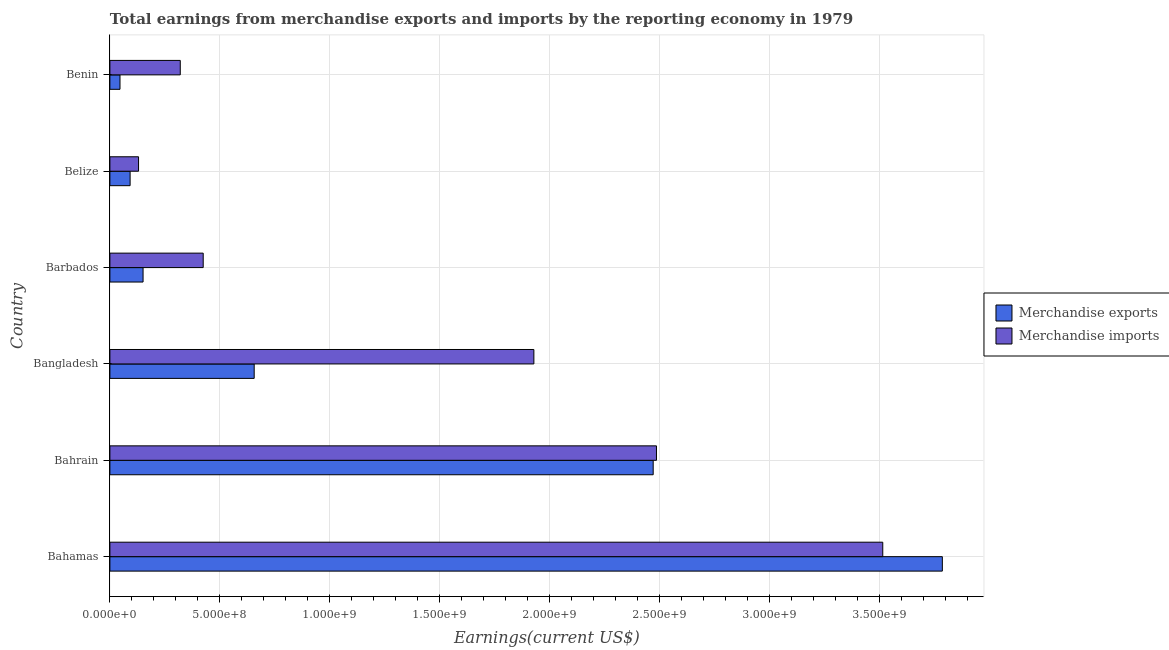How many different coloured bars are there?
Your response must be concise. 2. Are the number of bars per tick equal to the number of legend labels?
Keep it short and to the point. Yes. What is the label of the 2nd group of bars from the top?
Make the answer very short. Belize. In how many cases, is the number of bars for a given country not equal to the number of legend labels?
Give a very brief answer. 0. What is the earnings from merchandise exports in Belize?
Your answer should be compact. 9.19e+07. Across all countries, what is the maximum earnings from merchandise imports?
Your response must be concise. 3.51e+09. Across all countries, what is the minimum earnings from merchandise exports?
Your answer should be compact. 4.59e+07. In which country was the earnings from merchandise exports maximum?
Provide a succinct answer. Bahamas. In which country was the earnings from merchandise exports minimum?
Make the answer very short. Benin. What is the total earnings from merchandise imports in the graph?
Make the answer very short. 8.80e+09. What is the difference between the earnings from merchandise exports in Bahamas and that in Benin?
Provide a succinct answer. 3.74e+09. What is the difference between the earnings from merchandise imports in Bangladesh and the earnings from merchandise exports in Bahamas?
Offer a very short reply. -1.86e+09. What is the average earnings from merchandise exports per country?
Your response must be concise. 1.20e+09. What is the difference between the earnings from merchandise exports and earnings from merchandise imports in Bahamas?
Make the answer very short. 2.71e+08. In how many countries, is the earnings from merchandise imports greater than 3500000000 US$?
Give a very brief answer. 1. What is the ratio of the earnings from merchandise imports in Bangladesh to that in Belize?
Make the answer very short. 14.79. What is the difference between the highest and the second highest earnings from merchandise exports?
Your answer should be very brief. 1.31e+09. What is the difference between the highest and the lowest earnings from merchandise exports?
Make the answer very short. 3.74e+09. Is the sum of the earnings from merchandise exports in Bangladesh and Benin greater than the maximum earnings from merchandise imports across all countries?
Your response must be concise. No. What does the 2nd bar from the top in Belize represents?
Give a very brief answer. Merchandise exports. What does the 2nd bar from the bottom in Benin represents?
Provide a short and direct response. Merchandise imports. Are all the bars in the graph horizontal?
Provide a short and direct response. Yes. How many countries are there in the graph?
Ensure brevity in your answer.  6. What is the difference between two consecutive major ticks on the X-axis?
Provide a succinct answer. 5.00e+08. Are the values on the major ticks of X-axis written in scientific E-notation?
Make the answer very short. Yes. How many legend labels are there?
Your answer should be very brief. 2. How are the legend labels stacked?
Provide a short and direct response. Vertical. What is the title of the graph?
Keep it short and to the point. Total earnings from merchandise exports and imports by the reporting economy in 1979. Does "Services" appear as one of the legend labels in the graph?
Your answer should be very brief. No. What is the label or title of the X-axis?
Ensure brevity in your answer.  Earnings(current US$). What is the label or title of the Y-axis?
Give a very brief answer. Country. What is the Earnings(current US$) in Merchandise exports in Bahamas?
Offer a very short reply. 3.78e+09. What is the Earnings(current US$) in Merchandise imports in Bahamas?
Provide a short and direct response. 3.51e+09. What is the Earnings(current US$) of Merchandise exports in Bahrain?
Ensure brevity in your answer.  2.47e+09. What is the Earnings(current US$) in Merchandise imports in Bahrain?
Offer a very short reply. 2.49e+09. What is the Earnings(current US$) of Merchandise exports in Bangladesh?
Your response must be concise. 6.56e+08. What is the Earnings(current US$) in Merchandise imports in Bangladesh?
Keep it short and to the point. 1.93e+09. What is the Earnings(current US$) in Merchandise exports in Barbados?
Offer a terse response. 1.51e+08. What is the Earnings(current US$) of Merchandise imports in Barbados?
Provide a succinct answer. 4.24e+08. What is the Earnings(current US$) of Merchandise exports in Belize?
Give a very brief answer. 9.19e+07. What is the Earnings(current US$) of Merchandise imports in Belize?
Your answer should be very brief. 1.30e+08. What is the Earnings(current US$) in Merchandise exports in Benin?
Offer a terse response. 4.59e+07. What is the Earnings(current US$) of Merchandise imports in Benin?
Your answer should be compact. 3.20e+08. Across all countries, what is the maximum Earnings(current US$) in Merchandise exports?
Offer a terse response. 3.78e+09. Across all countries, what is the maximum Earnings(current US$) in Merchandise imports?
Offer a terse response. 3.51e+09. Across all countries, what is the minimum Earnings(current US$) in Merchandise exports?
Your answer should be very brief. 4.59e+07. Across all countries, what is the minimum Earnings(current US$) of Merchandise imports?
Keep it short and to the point. 1.30e+08. What is the total Earnings(current US$) of Merchandise exports in the graph?
Ensure brevity in your answer.  7.20e+09. What is the total Earnings(current US$) in Merchandise imports in the graph?
Give a very brief answer. 8.80e+09. What is the difference between the Earnings(current US$) in Merchandise exports in Bahamas and that in Bahrain?
Your answer should be compact. 1.31e+09. What is the difference between the Earnings(current US$) of Merchandise imports in Bahamas and that in Bahrain?
Provide a succinct answer. 1.03e+09. What is the difference between the Earnings(current US$) of Merchandise exports in Bahamas and that in Bangladesh?
Your answer should be compact. 3.13e+09. What is the difference between the Earnings(current US$) of Merchandise imports in Bahamas and that in Bangladesh?
Your answer should be compact. 1.59e+09. What is the difference between the Earnings(current US$) of Merchandise exports in Bahamas and that in Barbados?
Provide a short and direct response. 3.63e+09. What is the difference between the Earnings(current US$) in Merchandise imports in Bahamas and that in Barbados?
Your response must be concise. 3.09e+09. What is the difference between the Earnings(current US$) of Merchandise exports in Bahamas and that in Belize?
Give a very brief answer. 3.69e+09. What is the difference between the Earnings(current US$) of Merchandise imports in Bahamas and that in Belize?
Provide a succinct answer. 3.38e+09. What is the difference between the Earnings(current US$) of Merchandise exports in Bahamas and that in Benin?
Offer a very short reply. 3.74e+09. What is the difference between the Earnings(current US$) of Merchandise imports in Bahamas and that in Benin?
Give a very brief answer. 3.19e+09. What is the difference between the Earnings(current US$) of Merchandise exports in Bahrain and that in Bangladesh?
Provide a short and direct response. 1.81e+09. What is the difference between the Earnings(current US$) in Merchandise imports in Bahrain and that in Bangladesh?
Offer a very short reply. 5.57e+08. What is the difference between the Earnings(current US$) in Merchandise exports in Bahrain and that in Barbados?
Your response must be concise. 2.32e+09. What is the difference between the Earnings(current US$) of Merchandise imports in Bahrain and that in Barbados?
Ensure brevity in your answer.  2.06e+09. What is the difference between the Earnings(current US$) in Merchandise exports in Bahrain and that in Belize?
Provide a succinct answer. 2.38e+09. What is the difference between the Earnings(current US$) in Merchandise imports in Bahrain and that in Belize?
Your answer should be compact. 2.35e+09. What is the difference between the Earnings(current US$) in Merchandise exports in Bahrain and that in Benin?
Provide a short and direct response. 2.42e+09. What is the difference between the Earnings(current US$) in Merchandise imports in Bahrain and that in Benin?
Your answer should be very brief. 2.17e+09. What is the difference between the Earnings(current US$) of Merchandise exports in Bangladesh and that in Barbados?
Your answer should be very brief. 5.05e+08. What is the difference between the Earnings(current US$) in Merchandise imports in Bangladesh and that in Barbados?
Your answer should be very brief. 1.50e+09. What is the difference between the Earnings(current US$) of Merchandise exports in Bangladesh and that in Belize?
Provide a short and direct response. 5.64e+08. What is the difference between the Earnings(current US$) in Merchandise imports in Bangladesh and that in Belize?
Your response must be concise. 1.80e+09. What is the difference between the Earnings(current US$) in Merchandise exports in Bangladesh and that in Benin?
Offer a very short reply. 6.10e+08. What is the difference between the Earnings(current US$) in Merchandise imports in Bangladesh and that in Benin?
Offer a terse response. 1.61e+09. What is the difference between the Earnings(current US$) in Merchandise exports in Barbados and that in Belize?
Your answer should be compact. 5.89e+07. What is the difference between the Earnings(current US$) of Merchandise imports in Barbados and that in Belize?
Keep it short and to the point. 2.94e+08. What is the difference between the Earnings(current US$) of Merchandise exports in Barbados and that in Benin?
Your response must be concise. 1.05e+08. What is the difference between the Earnings(current US$) in Merchandise imports in Barbados and that in Benin?
Provide a short and direct response. 1.04e+08. What is the difference between the Earnings(current US$) of Merchandise exports in Belize and that in Benin?
Your answer should be compact. 4.60e+07. What is the difference between the Earnings(current US$) of Merchandise imports in Belize and that in Benin?
Make the answer very short. -1.90e+08. What is the difference between the Earnings(current US$) of Merchandise exports in Bahamas and the Earnings(current US$) of Merchandise imports in Bahrain?
Offer a terse response. 1.30e+09. What is the difference between the Earnings(current US$) of Merchandise exports in Bahamas and the Earnings(current US$) of Merchandise imports in Bangladesh?
Offer a terse response. 1.86e+09. What is the difference between the Earnings(current US$) of Merchandise exports in Bahamas and the Earnings(current US$) of Merchandise imports in Barbados?
Your answer should be very brief. 3.36e+09. What is the difference between the Earnings(current US$) in Merchandise exports in Bahamas and the Earnings(current US$) in Merchandise imports in Belize?
Your answer should be compact. 3.65e+09. What is the difference between the Earnings(current US$) of Merchandise exports in Bahamas and the Earnings(current US$) of Merchandise imports in Benin?
Keep it short and to the point. 3.46e+09. What is the difference between the Earnings(current US$) of Merchandise exports in Bahrain and the Earnings(current US$) of Merchandise imports in Bangladesh?
Offer a terse response. 5.42e+08. What is the difference between the Earnings(current US$) of Merchandise exports in Bahrain and the Earnings(current US$) of Merchandise imports in Barbados?
Offer a terse response. 2.05e+09. What is the difference between the Earnings(current US$) in Merchandise exports in Bahrain and the Earnings(current US$) in Merchandise imports in Belize?
Offer a very short reply. 2.34e+09. What is the difference between the Earnings(current US$) of Merchandise exports in Bahrain and the Earnings(current US$) of Merchandise imports in Benin?
Give a very brief answer. 2.15e+09. What is the difference between the Earnings(current US$) in Merchandise exports in Bangladesh and the Earnings(current US$) in Merchandise imports in Barbados?
Make the answer very short. 2.32e+08. What is the difference between the Earnings(current US$) in Merchandise exports in Bangladesh and the Earnings(current US$) in Merchandise imports in Belize?
Provide a succinct answer. 5.26e+08. What is the difference between the Earnings(current US$) of Merchandise exports in Bangladesh and the Earnings(current US$) of Merchandise imports in Benin?
Offer a terse response. 3.36e+08. What is the difference between the Earnings(current US$) in Merchandise exports in Barbados and the Earnings(current US$) in Merchandise imports in Belize?
Your answer should be very brief. 2.05e+07. What is the difference between the Earnings(current US$) in Merchandise exports in Barbados and the Earnings(current US$) in Merchandise imports in Benin?
Make the answer very short. -1.69e+08. What is the difference between the Earnings(current US$) of Merchandise exports in Belize and the Earnings(current US$) of Merchandise imports in Benin?
Ensure brevity in your answer.  -2.28e+08. What is the average Earnings(current US$) in Merchandise exports per country?
Keep it short and to the point. 1.20e+09. What is the average Earnings(current US$) in Merchandise imports per country?
Give a very brief answer. 1.47e+09. What is the difference between the Earnings(current US$) of Merchandise exports and Earnings(current US$) of Merchandise imports in Bahamas?
Give a very brief answer. 2.71e+08. What is the difference between the Earnings(current US$) of Merchandise exports and Earnings(current US$) of Merchandise imports in Bahrain?
Provide a succinct answer. -1.50e+07. What is the difference between the Earnings(current US$) in Merchandise exports and Earnings(current US$) in Merchandise imports in Bangladesh?
Your answer should be compact. -1.27e+09. What is the difference between the Earnings(current US$) in Merchandise exports and Earnings(current US$) in Merchandise imports in Barbados?
Keep it short and to the point. -2.73e+08. What is the difference between the Earnings(current US$) of Merchandise exports and Earnings(current US$) of Merchandise imports in Belize?
Offer a terse response. -3.84e+07. What is the difference between the Earnings(current US$) in Merchandise exports and Earnings(current US$) in Merchandise imports in Benin?
Offer a terse response. -2.74e+08. What is the ratio of the Earnings(current US$) of Merchandise exports in Bahamas to that in Bahrain?
Make the answer very short. 1.53. What is the ratio of the Earnings(current US$) of Merchandise imports in Bahamas to that in Bahrain?
Provide a short and direct response. 1.41. What is the ratio of the Earnings(current US$) of Merchandise exports in Bahamas to that in Bangladesh?
Offer a very short reply. 5.77. What is the ratio of the Earnings(current US$) in Merchandise imports in Bahamas to that in Bangladesh?
Offer a terse response. 1.82. What is the ratio of the Earnings(current US$) in Merchandise exports in Bahamas to that in Barbados?
Give a very brief answer. 25.09. What is the ratio of the Earnings(current US$) in Merchandise imports in Bahamas to that in Barbados?
Make the answer very short. 8.28. What is the ratio of the Earnings(current US$) in Merchandise exports in Bahamas to that in Belize?
Your response must be concise. 41.17. What is the ratio of the Earnings(current US$) of Merchandise imports in Bahamas to that in Belize?
Keep it short and to the point. 26.97. What is the ratio of the Earnings(current US$) in Merchandise exports in Bahamas to that in Benin?
Ensure brevity in your answer.  82.38. What is the ratio of the Earnings(current US$) in Merchandise imports in Bahamas to that in Benin?
Provide a succinct answer. 10.98. What is the ratio of the Earnings(current US$) of Merchandise exports in Bahrain to that in Bangladesh?
Keep it short and to the point. 3.77. What is the ratio of the Earnings(current US$) in Merchandise imports in Bahrain to that in Bangladesh?
Offer a terse response. 1.29. What is the ratio of the Earnings(current US$) of Merchandise exports in Bahrain to that in Barbados?
Provide a succinct answer. 16.38. What is the ratio of the Earnings(current US$) in Merchandise imports in Bahrain to that in Barbados?
Offer a terse response. 5.86. What is the ratio of the Earnings(current US$) in Merchandise exports in Bahrain to that in Belize?
Provide a short and direct response. 26.87. What is the ratio of the Earnings(current US$) in Merchandise imports in Bahrain to that in Belize?
Provide a short and direct response. 19.07. What is the ratio of the Earnings(current US$) of Merchandise exports in Bahrain to that in Benin?
Offer a very short reply. 53.76. What is the ratio of the Earnings(current US$) of Merchandise imports in Bahrain to that in Benin?
Offer a terse response. 7.77. What is the ratio of the Earnings(current US$) of Merchandise exports in Bangladesh to that in Barbados?
Give a very brief answer. 4.35. What is the ratio of the Earnings(current US$) in Merchandise imports in Bangladesh to that in Barbados?
Ensure brevity in your answer.  4.54. What is the ratio of the Earnings(current US$) of Merchandise exports in Bangladesh to that in Belize?
Offer a terse response. 7.14. What is the ratio of the Earnings(current US$) in Merchandise imports in Bangladesh to that in Belize?
Give a very brief answer. 14.79. What is the ratio of the Earnings(current US$) in Merchandise exports in Bangladesh to that in Benin?
Keep it short and to the point. 14.28. What is the ratio of the Earnings(current US$) in Merchandise imports in Bangladesh to that in Benin?
Provide a succinct answer. 6.02. What is the ratio of the Earnings(current US$) in Merchandise exports in Barbados to that in Belize?
Ensure brevity in your answer.  1.64. What is the ratio of the Earnings(current US$) in Merchandise imports in Barbados to that in Belize?
Provide a short and direct response. 3.26. What is the ratio of the Earnings(current US$) in Merchandise exports in Barbados to that in Benin?
Your answer should be compact. 3.28. What is the ratio of the Earnings(current US$) in Merchandise imports in Barbados to that in Benin?
Offer a terse response. 1.33. What is the ratio of the Earnings(current US$) in Merchandise exports in Belize to that in Benin?
Your answer should be compact. 2. What is the ratio of the Earnings(current US$) of Merchandise imports in Belize to that in Benin?
Your answer should be very brief. 0.41. What is the difference between the highest and the second highest Earnings(current US$) of Merchandise exports?
Offer a very short reply. 1.31e+09. What is the difference between the highest and the second highest Earnings(current US$) of Merchandise imports?
Give a very brief answer. 1.03e+09. What is the difference between the highest and the lowest Earnings(current US$) in Merchandise exports?
Offer a very short reply. 3.74e+09. What is the difference between the highest and the lowest Earnings(current US$) in Merchandise imports?
Your response must be concise. 3.38e+09. 